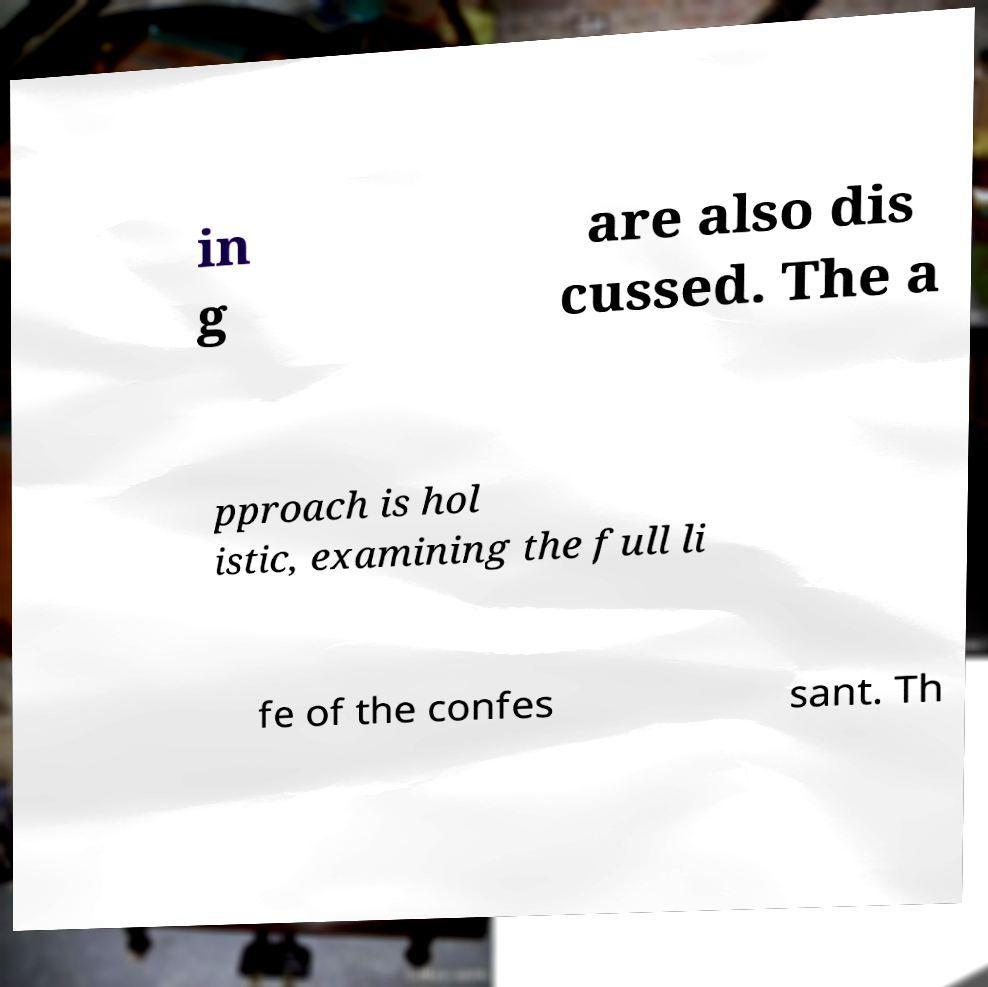Please read and relay the text visible in this image. What does it say? in g are also dis cussed. The a pproach is hol istic, examining the full li fe of the confes sant. Th 